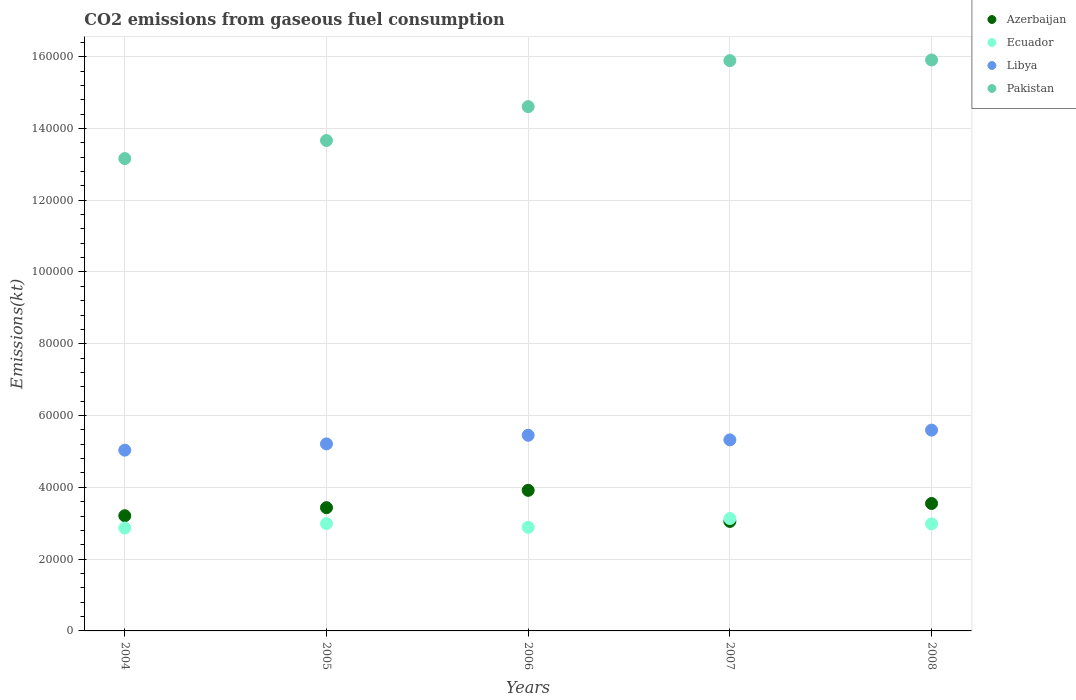Is the number of dotlines equal to the number of legend labels?
Offer a terse response. Yes. What is the amount of CO2 emitted in Azerbaijan in 2007?
Your answer should be very brief. 3.05e+04. Across all years, what is the maximum amount of CO2 emitted in Ecuador?
Your answer should be compact. 3.13e+04. Across all years, what is the minimum amount of CO2 emitted in Ecuador?
Give a very brief answer. 2.87e+04. In which year was the amount of CO2 emitted in Azerbaijan maximum?
Offer a very short reply. 2006. In which year was the amount of CO2 emitted in Ecuador minimum?
Give a very brief answer. 2004. What is the total amount of CO2 emitted in Pakistan in the graph?
Offer a terse response. 7.32e+05. What is the difference between the amount of CO2 emitted in Pakistan in 2004 and that in 2005?
Your response must be concise. -5034.79. What is the difference between the amount of CO2 emitted in Pakistan in 2004 and the amount of CO2 emitted in Libya in 2007?
Your answer should be compact. 7.84e+04. What is the average amount of CO2 emitted in Libya per year?
Your answer should be very brief. 5.32e+04. In the year 2008, what is the difference between the amount of CO2 emitted in Pakistan and amount of CO2 emitted in Libya?
Ensure brevity in your answer.  1.03e+05. In how many years, is the amount of CO2 emitted in Azerbaijan greater than 132000 kt?
Your answer should be compact. 0. What is the ratio of the amount of CO2 emitted in Libya in 2004 to that in 2008?
Ensure brevity in your answer.  0.9. Is the difference between the amount of CO2 emitted in Pakistan in 2004 and 2007 greater than the difference between the amount of CO2 emitted in Libya in 2004 and 2007?
Your response must be concise. No. What is the difference between the highest and the second highest amount of CO2 emitted in Azerbaijan?
Make the answer very short. 3663.33. What is the difference between the highest and the lowest amount of CO2 emitted in Azerbaijan?
Offer a very short reply. 8657.79. Is it the case that in every year, the sum of the amount of CO2 emitted in Libya and amount of CO2 emitted in Azerbaijan  is greater than the sum of amount of CO2 emitted in Ecuador and amount of CO2 emitted in Pakistan?
Your answer should be very brief. No. Is it the case that in every year, the sum of the amount of CO2 emitted in Ecuador and amount of CO2 emitted in Libya  is greater than the amount of CO2 emitted in Azerbaijan?
Your answer should be very brief. Yes. Does the amount of CO2 emitted in Ecuador monotonically increase over the years?
Your answer should be very brief. No. Is the amount of CO2 emitted in Pakistan strictly less than the amount of CO2 emitted in Ecuador over the years?
Offer a terse response. No. How many dotlines are there?
Your response must be concise. 4. How many years are there in the graph?
Keep it short and to the point. 5. Are the values on the major ticks of Y-axis written in scientific E-notation?
Offer a very short reply. No. Does the graph contain any zero values?
Offer a very short reply. No. Where does the legend appear in the graph?
Provide a succinct answer. Top right. How many legend labels are there?
Ensure brevity in your answer.  4. How are the legend labels stacked?
Offer a very short reply. Vertical. What is the title of the graph?
Ensure brevity in your answer.  CO2 emissions from gaseous fuel consumption. What is the label or title of the Y-axis?
Ensure brevity in your answer.  Emissions(kt). What is the Emissions(kt) in Azerbaijan in 2004?
Your answer should be very brief. 3.21e+04. What is the Emissions(kt) of Ecuador in 2004?
Offer a very short reply. 2.87e+04. What is the Emissions(kt) in Libya in 2004?
Your answer should be very brief. 5.04e+04. What is the Emissions(kt) in Pakistan in 2004?
Keep it short and to the point. 1.32e+05. What is the Emissions(kt) in Azerbaijan in 2005?
Your response must be concise. 3.43e+04. What is the Emissions(kt) of Ecuador in 2005?
Your answer should be compact. 2.99e+04. What is the Emissions(kt) in Libya in 2005?
Give a very brief answer. 5.21e+04. What is the Emissions(kt) in Pakistan in 2005?
Your answer should be compact. 1.37e+05. What is the Emissions(kt) in Azerbaijan in 2006?
Your response must be concise. 3.92e+04. What is the Emissions(kt) in Ecuador in 2006?
Offer a very short reply. 2.89e+04. What is the Emissions(kt) in Libya in 2006?
Your response must be concise. 5.45e+04. What is the Emissions(kt) of Pakistan in 2006?
Ensure brevity in your answer.  1.46e+05. What is the Emissions(kt) in Azerbaijan in 2007?
Your answer should be compact. 3.05e+04. What is the Emissions(kt) in Ecuador in 2007?
Provide a succinct answer. 3.13e+04. What is the Emissions(kt) in Libya in 2007?
Offer a terse response. 5.32e+04. What is the Emissions(kt) in Pakistan in 2007?
Provide a succinct answer. 1.59e+05. What is the Emissions(kt) in Azerbaijan in 2008?
Your answer should be compact. 3.55e+04. What is the Emissions(kt) in Ecuador in 2008?
Your answer should be compact. 2.98e+04. What is the Emissions(kt) of Libya in 2008?
Offer a terse response. 5.59e+04. What is the Emissions(kt) of Pakistan in 2008?
Your response must be concise. 1.59e+05. Across all years, what is the maximum Emissions(kt) of Azerbaijan?
Offer a very short reply. 3.92e+04. Across all years, what is the maximum Emissions(kt) in Ecuador?
Give a very brief answer. 3.13e+04. Across all years, what is the maximum Emissions(kt) in Libya?
Your answer should be very brief. 5.59e+04. Across all years, what is the maximum Emissions(kt) in Pakistan?
Provide a succinct answer. 1.59e+05. Across all years, what is the minimum Emissions(kt) of Azerbaijan?
Your answer should be very brief. 3.05e+04. Across all years, what is the minimum Emissions(kt) of Ecuador?
Keep it short and to the point. 2.87e+04. Across all years, what is the minimum Emissions(kt) in Libya?
Offer a terse response. 5.04e+04. Across all years, what is the minimum Emissions(kt) of Pakistan?
Your answer should be very brief. 1.32e+05. What is the total Emissions(kt) in Azerbaijan in the graph?
Offer a terse response. 1.72e+05. What is the total Emissions(kt) of Ecuador in the graph?
Your response must be concise. 1.49e+05. What is the total Emissions(kt) of Libya in the graph?
Your response must be concise. 2.66e+05. What is the total Emissions(kt) of Pakistan in the graph?
Offer a very short reply. 7.32e+05. What is the difference between the Emissions(kt) of Azerbaijan in 2004 and that in 2005?
Ensure brevity in your answer.  -2247.87. What is the difference between the Emissions(kt) of Ecuador in 2004 and that in 2005?
Your answer should be compact. -1250.45. What is the difference between the Emissions(kt) in Libya in 2004 and that in 2005?
Make the answer very short. -1749.16. What is the difference between the Emissions(kt) of Pakistan in 2004 and that in 2005?
Ensure brevity in your answer.  -5034.79. What is the difference between the Emissions(kt) of Azerbaijan in 2004 and that in 2006?
Make the answer very short. -7077.31. What is the difference between the Emissions(kt) of Ecuador in 2004 and that in 2006?
Provide a short and direct response. -201.69. What is the difference between the Emissions(kt) in Libya in 2004 and that in 2006?
Give a very brief answer. -4151.04. What is the difference between the Emissions(kt) of Pakistan in 2004 and that in 2006?
Your answer should be very brief. -1.45e+04. What is the difference between the Emissions(kt) of Azerbaijan in 2004 and that in 2007?
Offer a very short reply. 1580.48. What is the difference between the Emissions(kt) of Ecuador in 2004 and that in 2007?
Make the answer very short. -2651.24. What is the difference between the Emissions(kt) in Libya in 2004 and that in 2007?
Keep it short and to the point. -2871.26. What is the difference between the Emissions(kt) in Pakistan in 2004 and that in 2007?
Provide a short and direct response. -2.73e+04. What is the difference between the Emissions(kt) of Azerbaijan in 2004 and that in 2008?
Your response must be concise. -3413.98. What is the difference between the Emissions(kt) of Ecuador in 2004 and that in 2008?
Your response must be concise. -1169.77. What is the difference between the Emissions(kt) of Libya in 2004 and that in 2008?
Provide a succinct answer. -5584.84. What is the difference between the Emissions(kt) of Pakistan in 2004 and that in 2008?
Make the answer very short. -2.75e+04. What is the difference between the Emissions(kt) in Azerbaijan in 2005 and that in 2006?
Make the answer very short. -4829.44. What is the difference between the Emissions(kt) in Ecuador in 2005 and that in 2006?
Offer a very short reply. 1048.76. What is the difference between the Emissions(kt) in Libya in 2005 and that in 2006?
Give a very brief answer. -2401.89. What is the difference between the Emissions(kt) of Pakistan in 2005 and that in 2006?
Your answer should be very brief. -9438.86. What is the difference between the Emissions(kt) of Azerbaijan in 2005 and that in 2007?
Your answer should be compact. 3828.35. What is the difference between the Emissions(kt) in Ecuador in 2005 and that in 2007?
Offer a very short reply. -1400.79. What is the difference between the Emissions(kt) of Libya in 2005 and that in 2007?
Your response must be concise. -1122.1. What is the difference between the Emissions(kt) in Pakistan in 2005 and that in 2007?
Make the answer very short. -2.23e+04. What is the difference between the Emissions(kt) in Azerbaijan in 2005 and that in 2008?
Provide a short and direct response. -1166.11. What is the difference between the Emissions(kt) of Ecuador in 2005 and that in 2008?
Your answer should be very brief. 80.67. What is the difference between the Emissions(kt) of Libya in 2005 and that in 2008?
Provide a succinct answer. -3835.68. What is the difference between the Emissions(kt) of Pakistan in 2005 and that in 2008?
Offer a very short reply. -2.24e+04. What is the difference between the Emissions(kt) in Azerbaijan in 2006 and that in 2007?
Your response must be concise. 8657.79. What is the difference between the Emissions(kt) of Ecuador in 2006 and that in 2007?
Your answer should be compact. -2449.56. What is the difference between the Emissions(kt) in Libya in 2006 and that in 2007?
Your response must be concise. 1279.78. What is the difference between the Emissions(kt) of Pakistan in 2006 and that in 2007?
Make the answer very short. -1.28e+04. What is the difference between the Emissions(kt) in Azerbaijan in 2006 and that in 2008?
Give a very brief answer. 3663.33. What is the difference between the Emissions(kt) of Ecuador in 2006 and that in 2008?
Give a very brief answer. -968.09. What is the difference between the Emissions(kt) of Libya in 2006 and that in 2008?
Your response must be concise. -1433.8. What is the difference between the Emissions(kt) of Pakistan in 2006 and that in 2008?
Give a very brief answer. -1.30e+04. What is the difference between the Emissions(kt) in Azerbaijan in 2007 and that in 2008?
Your answer should be very brief. -4994.45. What is the difference between the Emissions(kt) of Ecuador in 2007 and that in 2008?
Offer a very short reply. 1481.47. What is the difference between the Emissions(kt) in Libya in 2007 and that in 2008?
Provide a short and direct response. -2713.58. What is the difference between the Emissions(kt) of Pakistan in 2007 and that in 2008?
Ensure brevity in your answer.  -176.02. What is the difference between the Emissions(kt) in Azerbaijan in 2004 and the Emissions(kt) in Ecuador in 2005?
Your answer should be very brief. 2181.86. What is the difference between the Emissions(kt) of Azerbaijan in 2004 and the Emissions(kt) of Libya in 2005?
Ensure brevity in your answer.  -2.00e+04. What is the difference between the Emissions(kt) of Azerbaijan in 2004 and the Emissions(kt) of Pakistan in 2005?
Your answer should be very brief. -1.05e+05. What is the difference between the Emissions(kt) in Ecuador in 2004 and the Emissions(kt) in Libya in 2005?
Your answer should be very brief. -2.35e+04. What is the difference between the Emissions(kt) in Ecuador in 2004 and the Emissions(kt) in Pakistan in 2005?
Keep it short and to the point. -1.08e+05. What is the difference between the Emissions(kt) of Libya in 2004 and the Emissions(kt) of Pakistan in 2005?
Offer a terse response. -8.63e+04. What is the difference between the Emissions(kt) of Azerbaijan in 2004 and the Emissions(kt) of Ecuador in 2006?
Ensure brevity in your answer.  3230.63. What is the difference between the Emissions(kt) of Azerbaijan in 2004 and the Emissions(kt) of Libya in 2006?
Your answer should be very brief. -2.24e+04. What is the difference between the Emissions(kt) of Azerbaijan in 2004 and the Emissions(kt) of Pakistan in 2006?
Offer a very short reply. -1.14e+05. What is the difference between the Emissions(kt) in Ecuador in 2004 and the Emissions(kt) in Libya in 2006?
Your response must be concise. -2.59e+04. What is the difference between the Emissions(kt) in Ecuador in 2004 and the Emissions(kt) in Pakistan in 2006?
Make the answer very short. -1.17e+05. What is the difference between the Emissions(kt) in Libya in 2004 and the Emissions(kt) in Pakistan in 2006?
Provide a succinct answer. -9.57e+04. What is the difference between the Emissions(kt) in Azerbaijan in 2004 and the Emissions(kt) in Ecuador in 2007?
Your answer should be compact. 781.07. What is the difference between the Emissions(kt) in Azerbaijan in 2004 and the Emissions(kt) in Libya in 2007?
Offer a terse response. -2.11e+04. What is the difference between the Emissions(kt) of Azerbaijan in 2004 and the Emissions(kt) of Pakistan in 2007?
Offer a terse response. -1.27e+05. What is the difference between the Emissions(kt) in Ecuador in 2004 and the Emissions(kt) in Libya in 2007?
Provide a short and direct response. -2.46e+04. What is the difference between the Emissions(kt) in Ecuador in 2004 and the Emissions(kt) in Pakistan in 2007?
Ensure brevity in your answer.  -1.30e+05. What is the difference between the Emissions(kt) in Libya in 2004 and the Emissions(kt) in Pakistan in 2007?
Keep it short and to the point. -1.09e+05. What is the difference between the Emissions(kt) of Azerbaijan in 2004 and the Emissions(kt) of Ecuador in 2008?
Offer a terse response. 2262.54. What is the difference between the Emissions(kt) of Azerbaijan in 2004 and the Emissions(kt) of Libya in 2008?
Ensure brevity in your answer.  -2.39e+04. What is the difference between the Emissions(kt) of Azerbaijan in 2004 and the Emissions(kt) of Pakistan in 2008?
Your answer should be very brief. -1.27e+05. What is the difference between the Emissions(kt) of Ecuador in 2004 and the Emissions(kt) of Libya in 2008?
Make the answer very short. -2.73e+04. What is the difference between the Emissions(kt) in Ecuador in 2004 and the Emissions(kt) in Pakistan in 2008?
Your answer should be compact. -1.30e+05. What is the difference between the Emissions(kt) in Libya in 2004 and the Emissions(kt) in Pakistan in 2008?
Provide a succinct answer. -1.09e+05. What is the difference between the Emissions(kt) in Azerbaijan in 2005 and the Emissions(kt) in Ecuador in 2006?
Offer a terse response. 5478.5. What is the difference between the Emissions(kt) of Azerbaijan in 2005 and the Emissions(kt) of Libya in 2006?
Your answer should be very brief. -2.02e+04. What is the difference between the Emissions(kt) in Azerbaijan in 2005 and the Emissions(kt) in Pakistan in 2006?
Your answer should be very brief. -1.12e+05. What is the difference between the Emissions(kt) in Ecuador in 2005 and the Emissions(kt) in Libya in 2006?
Offer a terse response. -2.46e+04. What is the difference between the Emissions(kt) of Ecuador in 2005 and the Emissions(kt) of Pakistan in 2006?
Ensure brevity in your answer.  -1.16e+05. What is the difference between the Emissions(kt) of Libya in 2005 and the Emissions(kt) of Pakistan in 2006?
Provide a short and direct response. -9.40e+04. What is the difference between the Emissions(kt) of Azerbaijan in 2005 and the Emissions(kt) of Ecuador in 2007?
Your answer should be very brief. 3028.94. What is the difference between the Emissions(kt) of Azerbaijan in 2005 and the Emissions(kt) of Libya in 2007?
Ensure brevity in your answer.  -1.89e+04. What is the difference between the Emissions(kt) in Azerbaijan in 2005 and the Emissions(kt) in Pakistan in 2007?
Your response must be concise. -1.25e+05. What is the difference between the Emissions(kt) of Ecuador in 2005 and the Emissions(kt) of Libya in 2007?
Ensure brevity in your answer.  -2.33e+04. What is the difference between the Emissions(kt) of Ecuador in 2005 and the Emissions(kt) of Pakistan in 2007?
Ensure brevity in your answer.  -1.29e+05. What is the difference between the Emissions(kt) in Libya in 2005 and the Emissions(kt) in Pakistan in 2007?
Your response must be concise. -1.07e+05. What is the difference between the Emissions(kt) in Azerbaijan in 2005 and the Emissions(kt) in Ecuador in 2008?
Keep it short and to the point. 4510.41. What is the difference between the Emissions(kt) in Azerbaijan in 2005 and the Emissions(kt) in Libya in 2008?
Give a very brief answer. -2.16e+04. What is the difference between the Emissions(kt) of Azerbaijan in 2005 and the Emissions(kt) of Pakistan in 2008?
Your answer should be very brief. -1.25e+05. What is the difference between the Emissions(kt) in Ecuador in 2005 and the Emissions(kt) in Libya in 2008?
Provide a short and direct response. -2.60e+04. What is the difference between the Emissions(kt) of Ecuador in 2005 and the Emissions(kt) of Pakistan in 2008?
Keep it short and to the point. -1.29e+05. What is the difference between the Emissions(kt) of Libya in 2005 and the Emissions(kt) of Pakistan in 2008?
Your response must be concise. -1.07e+05. What is the difference between the Emissions(kt) in Azerbaijan in 2006 and the Emissions(kt) in Ecuador in 2007?
Offer a very short reply. 7858.38. What is the difference between the Emissions(kt) in Azerbaijan in 2006 and the Emissions(kt) in Libya in 2007?
Provide a succinct answer. -1.41e+04. What is the difference between the Emissions(kt) of Azerbaijan in 2006 and the Emissions(kt) of Pakistan in 2007?
Provide a succinct answer. -1.20e+05. What is the difference between the Emissions(kt) in Ecuador in 2006 and the Emissions(kt) in Libya in 2007?
Provide a succinct answer. -2.44e+04. What is the difference between the Emissions(kt) of Ecuador in 2006 and the Emissions(kt) of Pakistan in 2007?
Ensure brevity in your answer.  -1.30e+05. What is the difference between the Emissions(kt) of Libya in 2006 and the Emissions(kt) of Pakistan in 2007?
Make the answer very short. -1.04e+05. What is the difference between the Emissions(kt) of Azerbaijan in 2006 and the Emissions(kt) of Ecuador in 2008?
Keep it short and to the point. 9339.85. What is the difference between the Emissions(kt) in Azerbaijan in 2006 and the Emissions(kt) in Libya in 2008?
Provide a short and direct response. -1.68e+04. What is the difference between the Emissions(kt) in Azerbaijan in 2006 and the Emissions(kt) in Pakistan in 2008?
Your answer should be compact. -1.20e+05. What is the difference between the Emissions(kt) of Ecuador in 2006 and the Emissions(kt) of Libya in 2008?
Provide a succinct answer. -2.71e+04. What is the difference between the Emissions(kt) in Ecuador in 2006 and the Emissions(kt) in Pakistan in 2008?
Your response must be concise. -1.30e+05. What is the difference between the Emissions(kt) of Libya in 2006 and the Emissions(kt) of Pakistan in 2008?
Provide a short and direct response. -1.05e+05. What is the difference between the Emissions(kt) in Azerbaijan in 2007 and the Emissions(kt) in Ecuador in 2008?
Provide a short and direct response. 682.06. What is the difference between the Emissions(kt) in Azerbaijan in 2007 and the Emissions(kt) in Libya in 2008?
Your answer should be compact. -2.54e+04. What is the difference between the Emissions(kt) of Azerbaijan in 2007 and the Emissions(kt) of Pakistan in 2008?
Your answer should be compact. -1.29e+05. What is the difference between the Emissions(kt) in Ecuador in 2007 and the Emissions(kt) in Libya in 2008?
Your answer should be very brief. -2.46e+04. What is the difference between the Emissions(kt) in Ecuador in 2007 and the Emissions(kt) in Pakistan in 2008?
Your answer should be very brief. -1.28e+05. What is the difference between the Emissions(kt) of Libya in 2007 and the Emissions(kt) of Pakistan in 2008?
Offer a terse response. -1.06e+05. What is the average Emissions(kt) in Azerbaijan per year?
Keep it short and to the point. 3.43e+04. What is the average Emissions(kt) in Ecuador per year?
Ensure brevity in your answer.  2.97e+04. What is the average Emissions(kt) in Libya per year?
Offer a very short reply. 5.32e+04. What is the average Emissions(kt) of Pakistan per year?
Provide a short and direct response. 1.46e+05. In the year 2004, what is the difference between the Emissions(kt) in Azerbaijan and Emissions(kt) in Ecuador?
Your answer should be compact. 3432.31. In the year 2004, what is the difference between the Emissions(kt) in Azerbaijan and Emissions(kt) in Libya?
Make the answer very short. -1.83e+04. In the year 2004, what is the difference between the Emissions(kt) of Azerbaijan and Emissions(kt) of Pakistan?
Offer a terse response. -9.95e+04. In the year 2004, what is the difference between the Emissions(kt) of Ecuador and Emissions(kt) of Libya?
Your answer should be compact. -2.17e+04. In the year 2004, what is the difference between the Emissions(kt) of Ecuador and Emissions(kt) of Pakistan?
Provide a short and direct response. -1.03e+05. In the year 2004, what is the difference between the Emissions(kt) in Libya and Emissions(kt) in Pakistan?
Provide a succinct answer. -8.12e+04. In the year 2005, what is the difference between the Emissions(kt) of Azerbaijan and Emissions(kt) of Ecuador?
Your answer should be very brief. 4429.74. In the year 2005, what is the difference between the Emissions(kt) in Azerbaijan and Emissions(kt) in Libya?
Your response must be concise. -1.78e+04. In the year 2005, what is the difference between the Emissions(kt) of Azerbaijan and Emissions(kt) of Pakistan?
Your response must be concise. -1.02e+05. In the year 2005, what is the difference between the Emissions(kt) of Ecuador and Emissions(kt) of Libya?
Your answer should be very brief. -2.22e+04. In the year 2005, what is the difference between the Emissions(kt) in Ecuador and Emissions(kt) in Pakistan?
Keep it short and to the point. -1.07e+05. In the year 2005, what is the difference between the Emissions(kt) in Libya and Emissions(kt) in Pakistan?
Your answer should be compact. -8.45e+04. In the year 2006, what is the difference between the Emissions(kt) of Azerbaijan and Emissions(kt) of Ecuador?
Provide a short and direct response. 1.03e+04. In the year 2006, what is the difference between the Emissions(kt) in Azerbaijan and Emissions(kt) in Libya?
Make the answer very short. -1.53e+04. In the year 2006, what is the difference between the Emissions(kt) in Azerbaijan and Emissions(kt) in Pakistan?
Offer a terse response. -1.07e+05. In the year 2006, what is the difference between the Emissions(kt) in Ecuador and Emissions(kt) in Libya?
Give a very brief answer. -2.57e+04. In the year 2006, what is the difference between the Emissions(kt) in Ecuador and Emissions(kt) in Pakistan?
Provide a succinct answer. -1.17e+05. In the year 2006, what is the difference between the Emissions(kt) of Libya and Emissions(kt) of Pakistan?
Offer a terse response. -9.16e+04. In the year 2007, what is the difference between the Emissions(kt) in Azerbaijan and Emissions(kt) in Ecuador?
Provide a short and direct response. -799.41. In the year 2007, what is the difference between the Emissions(kt) in Azerbaijan and Emissions(kt) in Libya?
Your response must be concise. -2.27e+04. In the year 2007, what is the difference between the Emissions(kt) in Azerbaijan and Emissions(kt) in Pakistan?
Offer a very short reply. -1.28e+05. In the year 2007, what is the difference between the Emissions(kt) of Ecuador and Emissions(kt) of Libya?
Keep it short and to the point. -2.19e+04. In the year 2007, what is the difference between the Emissions(kt) in Ecuador and Emissions(kt) in Pakistan?
Your answer should be compact. -1.28e+05. In the year 2007, what is the difference between the Emissions(kt) in Libya and Emissions(kt) in Pakistan?
Your answer should be very brief. -1.06e+05. In the year 2008, what is the difference between the Emissions(kt) of Azerbaijan and Emissions(kt) of Ecuador?
Give a very brief answer. 5676.52. In the year 2008, what is the difference between the Emissions(kt) of Azerbaijan and Emissions(kt) of Libya?
Give a very brief answer. -2.04e+04. In the year 2008, what is the difference between the Emissions(kt) in Azerbaijan and Emissions(kt) in Pakistan?
Your answer should be very brief. -1.24e+05. In the year 2008, what is the difference between the Emissions(kt) in Ecuador and Emissions(kt) in Libya?
Ensure brevity in your answer.  -2.61e+04. In the year 2008, what is the difference between the Emissions(kt) in Ecuador and Emissions(kt) in Pakistan?
Ensure brevity in your answer.  -1.29e+05. In the year 2008, what is the difference between the Emissions(kt) of Libya and Emissions(kt) of Pakistan?
Ensure brevity in your answer.  -1.03e+05. What is the ratio of the Emissions(kt) of Azerbaijan in 2004 to that in 2005?
Keep it short and to the point. 0.93. What is the ratio of the Emissions(kt) of Ecuador in 2004 to that in 2005?
Offer a terse response. 0.96. What is the ratio of the Emissions(kt) of Libya in 2004 to that in 2005?
Provide a succinct answer. 0.97. What is the ratio of the Emissions(kt) of Pakistan in 2004 to that in 2005?
Provide a short and direct response. 0.96. What is the ratio of the Emissions(kt) in Azerbaijan in 2004 to that in 2006?
Ensure brevity in your answer.  0.82. What is the ratio of the Emissions(kt) of Libya in 2004 to that in 2006?
Ensure brevity in your answer.  0.92. What is the ratio of the Emissions(kt) in Pakistan in 2004 to that in 2006?
Offer a very short reply. 0.9. What is the ratio of the Emissions(kt) in Azerbaijan in 2004 to that in 2007?
Ensure brevity in your answer.  1.05. What is the ratio of the Emissions(kt) in Ecuador in 2004 to that in 2007?
Keep it short and to the point. 0.92. What is the ratio of the Emissions(kt) in Libya in 2004 to that in 2007?
Offer a terse response. 0.95. What is the ratio of the Emissions(kt) of Pakistan in 2004 to that in 2007?
Offer a very short reply. 0.83. What is the ratio of the Emissions(kt) in Azerbaijan in 2004 to that in 2008?
Ensure brevity in your answer.  0.9. What is the ratio of the Emissions(kt) of Ecuador in 2004 to that in 2008?
Offer a very short reply. 0.96. What is the ratio of the Emissions(kt) in Libya in 2004 to that in 2008?
Offer a terse response. 0.9. What is the ratio of the Emissions(kt) in Pakistan in 2004 to that in 2008?
Give a very brief answer. 0.83. What is the ratio of the Emissions(kt) of Azerbaijan in 2005 to that in 2006?
Offer a terse response. 0.88. What is the ratio of the Emissions(kt) of Ecuador in 2005 to that in 2006?
Provide a succinct answer. 1.04. What is the ratio of the Emissions(kt) of Libya in 2005 to that in 2006?
Make the answer very short. 0.96. What is the ratio of the Emissions(kt) in Pakistan in 2005 to that in 2006?
Give a very brief answer. 0.94. What is the ratio of the Emissions(kt) in Azerbaijan in 2005 to that in 2007?
Provide a succinct answer. 1.13. What is the ratio of the Emissions(kt) of Ecuador in 2005 to that in 2007?
Provide a succinct answer. 0.96. What is the ratio of the Emissions(kt) in Libya in 2005 to that in 2007?
Ensure brevity in your answer.  0.98. What is the ratio of the Emissions(kt) of Pakistan in 2005 to that in 2007?
Offer a very short reply. 0.86. What is the ratio of the Emissions(kt) in Azerbaijan in 2005 to that in 2008?
Make the answer very short. 0.97. What is the ratio of the Emissions(kt) of Libya in 2005 to that in 2008?
Provide a succinct answer. 0.93. What is the ratio of the Emissions(kt) in Pakistan in 2005 to that in 2008?
Your answer should be compact. 0.86. What is the ratio of the Emissions(kt) of Azerbaijan in 2006 to that in 2007?
Your response must be concise. 1.28. What is the ratio of the Emissions(kt) of Ecuador in 2006 to that in 2007?
Keep it short and to the point. 0.92. What is the ratio of the Emissions(kt) in Libya in 2006 to that in 2007?
Your answer should be very brief. 1.02. What is the ratio of the Emissions(kt) of Pakistan in 2006 to that in 2007?
Offer a very short reply. 0.92. What is the ratio of the Emissions(kt) of Azerbaijan in 2006 to that in 2008?
Your answer should be compact. 1.1. What is the ratio of the Emissions(kt) of Ecuador in 2006 to that in 2008?
Your answer should be compact. 0.97. What is the ratio of the Emissions(kt) of Libya in 2006 to that in 2008?
Your answer should be very brief. 0.97. What is the ratio of the Emissions(kt) in Pakistan in 2006 to that in 2008?
Your answer should be compact. 0.92. What is the ratio of the Emissions(kt) of Azerbaijan in 2007 to that in 2008?
Give a very brief answer. 0.86. What is the ratio of the Emissions(kt) of Ecuador in 2007 to that in 2008?
Offer a terse response. 1.05. What is the ratio of the Emissions(kt) in Libya in 2007 to that in 2008?
Provide a short and direct response. 0.95. What is the difference between the highest and the second highest Emissions(kt) in Azerbaijan?
Keep it short and to the point. 3663.33. What is the difference between the highest and the second highest Emissions(kt) in Ecuador?
Keep it short and to the point. 1400.79. What is the difference between the highest and the second highest Emissions(kt) in Libya?
Your answer should be very brief. 1433.8. What is the difference between the highest and the second highest Emissions(kt) of Pakistan?
Provide a short and direct response. 176.02. What is the difference between the highest and the lowest Emissions(kt) of Azerbaijan?
Make the answer very short. 8657.79. What is the difference between the highest and the lowest Emissions(kt) of Ecuador?
Make the answer very short. 2651.24. What is the difference between the highest and the lowest Emissions(kt) of Libya?
Offer a very short reply. 5584.84. What is the difference between the highest and the lowest Emissions(kt) in Pakistan?
Offer a very short reply. 2.75e+04. 